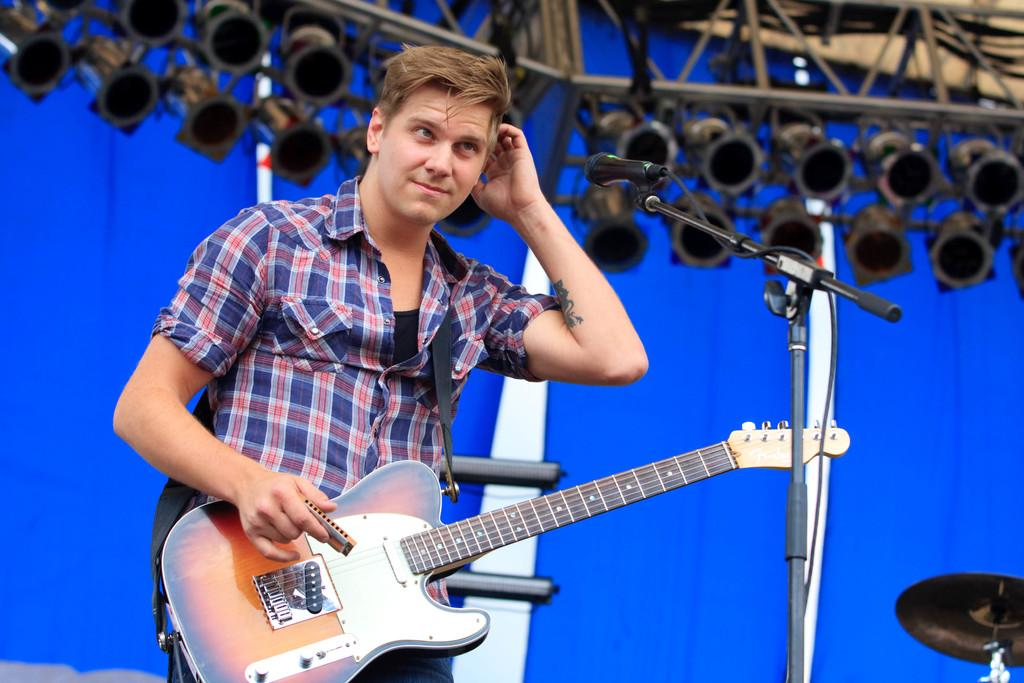Who is the person in the image? There is a man in the image. What is the man holding in the image? The man is carrying a guitar. What is the man positioned in front of in the image? The man is in front of a microphone. What color is the cloth in the background of the image? There is a blue cloth in the background of the image. What can be seen in the background of the image besides the cloth? There is equipment visible in the background of the image. What type of grass is growing around the man in the image? There is no grass visible in the image; it appears to be an indoor setting. 